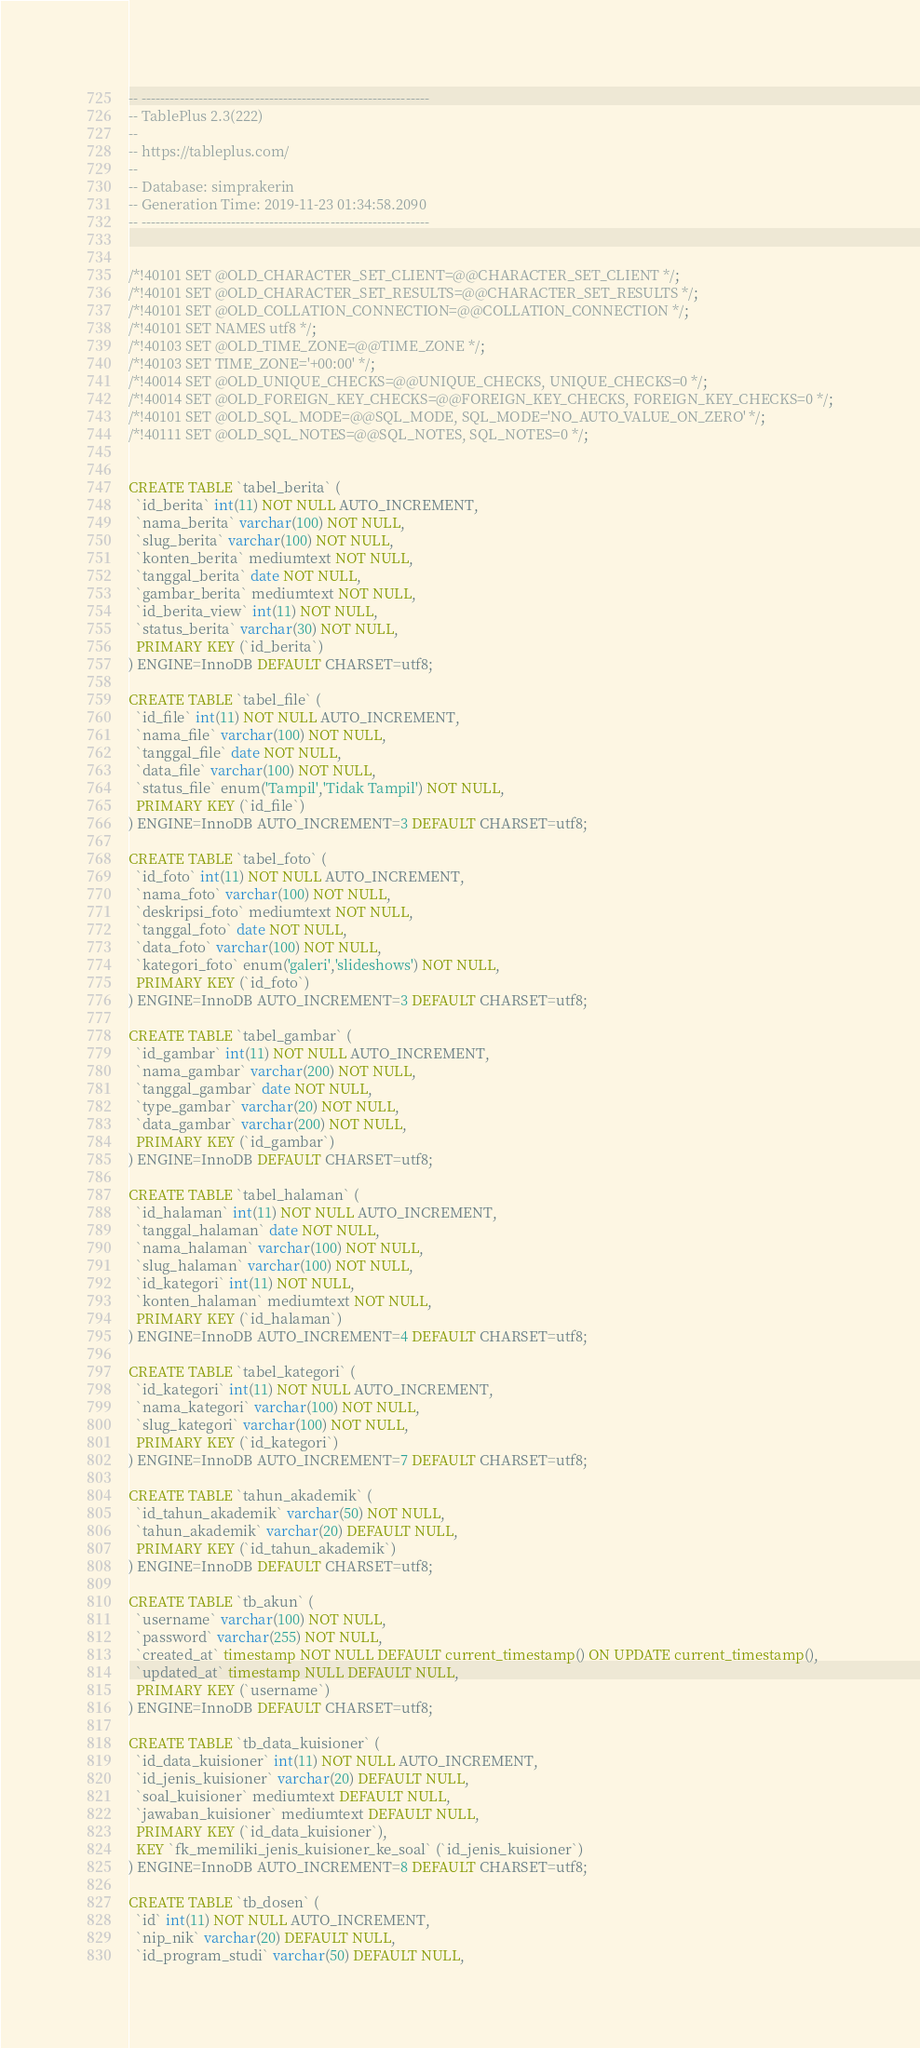Convert code to text. <code><loc_0><loc_0><loc_500><loc_500><_SQL_>-- -------------------------------------------------------------
-- TablePlus 2.3(222)
--
-- https://tableplus.com/
--
-- Database: simprakerin
-- Generation Time: 2019-11-23 01:34:58.2090
-- -------------------------------------------------------------


/*!40101 SET @OLD_CHARACTER_SET_CLIENT=@@CHARACTER_SET_CLIENT */;
/*!40101 SET @OLD_CHARACTER_SET_RESULTS=@@CHARACTER_SET_RESULTS */;
/*!40101 SET @OLD_COLLATION_CONNECTION=@@COLLATION_CONNECTION */;
/*!40101 SET NAMES utf8 */;
/*!40103 SET @OLD_TIME_ZONE=@@TIME_ZONE */;
/*!40103 SET TIME_ZONE='+00:00' */;
/*!40014 SET @OLD_UNIQUE_CHECKS=@@UNIQUE_CHECKS, UNIQUE_CHECKS=0 */;
/*!40014 SET @OLD_FOREIGN_KEY_CHECKS=@@FOREIGN_KEY_CHECKS, FOREIGN_KEY_CHECKS=0 */;
/*!40101 SET @OLD_SQL_MODE=@@SQL_MODE, SQL_MODE='NO_AUTO_VALUE_ON_ZERO' */;
/*!40111 SET @OLD_SQL_NOTES=@@SQL_NOTES, SQL_NOTES=0 */;


CREATE TABLE `tabel_berita` (
  `id_berita` int(11) NOT NULL AUTO_INCREMENT,
  `nama_berita` varchar(100) NOT NULL,
  `slug_berita` varchar(100) NOT NULL,
  `konten_berita` mediumtext NOT NULL,
  `tanggal_berita` date NOT NULL,
  `gambar_berita` mediumtext NOT NULL,
  `id_berita_view` int(11) NOT NULL,
  `status_berita` varchar(30) NOT NULL,
  PRIMARY KEY (`id_berita`)
) ENGINE=InnoDB DEFAULT CHARSET=utf8;

CREATE TABLE `tabel_file` (
  `id_file` int(11) NOT NULL AUTO_INCREMENT,
  `nama_file` varchar(100) NOT NULL,
  `tanggal_file` date NOT NULL,
  `data_file` varchar(100) NOT NULL,
  `status_file` enum('Tampil','Tidak Tampil') NOT NULL,
  PRIMARY KEY (`id_file`)
) ENGINE=InnoDB AUTO_INCREMENT=3 DEFAULT CHARSET=utf8;

CREATE TABLE `tabel_foto` (
  `id_foto` int(11) NOT NULL AUTO_INCREMENT,
  `nama_foto` varchar(100) NOT NULL,
  `deskripsi_foto` mediumtext NOT NULL,
  `tanggal_foto` date NOT NULL,
  `data_foto` varchar(100) NOT NULL,
  `kategori_foto` enum('galeri','slideshows') NOT NULL,
  PRIMARY KEY (`id_foto`)
) ENGINE=InnoDB AUTO_INCREMENT=3 DEFAULT CHARSET=utf8;

CREATE TABLE `tabel_gambar` (
  `id_gambar` int(11) NOT NULL AUTO_INCREMENT,
  `nama_gambar` varchar(200) NOT NULL,
  `tanggal_gambar` date NOT NULL,
  `type_gambar` varchar(20) NOT NULL,
  `data_gambar` varchar(200) NOT NULL,
  PRIMARY KEY (`id_gambar`)
) ENGINE=InnoDB DEFAULT CHARSET=utf8;

CREATE TABLE `tabel_halaman` (
  `id_halaman` int(11) NOT NULL AUTO_INCREMENT,
  `tanggal_halaman` date NOT NULL,
  `nama_halaman` varchar(100) NOT NULL,
  `slug_halaman` varchar(100) NOT NULL,
  `id_kategori` int(11) NOT NULL,
  `konten_halaman` mediumtext NOT NULL,
  PRIMARY KEY (`id_halaman`)
) ENGINE=InnoDB AUTO_INCREMENT=4 DEFAULT CHARSET=utf8;

CREATE TABLE `tabel_kategori` (
  `id_kategori` int(11) NOT NULL AUTO_INCREMENT,
  `nama_kategori` varchar(100) NOT NULL,
  `slug_kategori` varchar(100) NOT NULL,
  PRIMARY KEY (`id_kategori`)
) ENGINE=InnoDB AUTO_INCREMENT=7 DEFAULT CHARSET=utf8;

CREATE TABLE `tahun_akademik` (
  `id_tahun_akademik` varchar(50) NOT NULL,
  `tahun_akademik` varchar(20) DEFAULT NULL,
  PRIMARY KEY (`id_tahun_akademik`)
) ENGINE=InnoDB DEFAULT CHARSET=utf8;

CREATE TABLE `tb_akun` (
  `username` varchar(100) NOT NULL,
  `password` varchar(255) NOT NULL,
  `created_at` timestamp NOT NULL DEFAULT current_timestamp() ON UPDATE current_timestamp(),
  `updated_at` timestamp NULL DEFAULT NULL,
  PRIMARY KEY (`username`)
) ENGINE=InnoDB DEFAULT CHARSET=utf8;

CREATE TABLE `tb_data_kuisioner` (
  `id_data_kuisioner` int(11) NOT NULL AUTO_INCREMENT,
  `id_jenis_kuisioner` varchar(20) DEFAULT NULL,
  `soal_kuisioner` mediumtext DEFAULT NULL,
  `jawaban_kuisioner` mediumtext DEFAULT NULL,
  PRIMARY KEY (`id_data_kuisioner`),
  KEY `fk_memiliki_jenis_kuisioner_ke_soal` (`id_jenis_kuisioner`)
) ENGINE=InnoDB AUTO_INCREMENT=8 DEFAULT CHARSET=utf8;

CREATE TABLE `tb_dosen` (
  `id` int(11) NOT NULL AUTO_INCREMENT,
  `nip_nik` varchar(20) DEFAULT NULL,
  `id_program_studi` varchar(50) DEFAULT NULL,</code> 